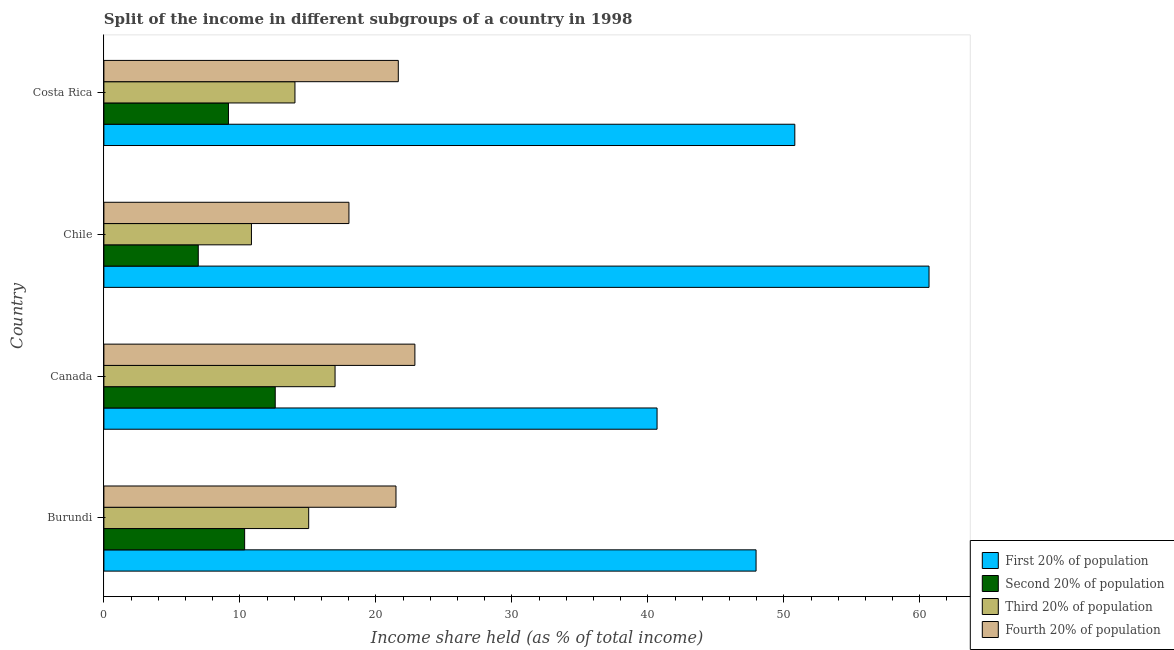How many different coloured bars are there?
Provide a succinct answer. 4. How many groups of bars are there?
Keep it short and to the point. 4. How many bars are there on the 1st tick from the top?
Your answer should be very brief. 4. How many bars are there on the 2nd tick from the bottom?
Offer a terse response. 4. What is the label of the 2nd group of bars from the top?
Give a very brief answer. Chile. What is the share of the income held by second 20% of the population in Chile?
Ensure brevity in your answer.  6.94. Across all countries, what is the maximum share of the income held by first 20% of the population?
Make the answer very short. 60.68. Across all countries, what is the minimum share of the income held by second 20% of the population?
Your answer should be compact. 6.94. What is the total share of the income held by third 20% of the population in the graph?
Give a very brief answer. 56.96. What is the difference between the share of the income held by second 20% of the population in Burundi and that in Canada?
Make the answer very short. -2.25. What is the difference between the share of the income held by third 20% of the population in Canada and the share of the income held by second 20% of the population in Chile?
Keep it short and to the point. 10.06. What is the average share of the income held by first 20% of the population per country?
Your response must be concise. 50.03. What is the difference between the share of the income held by first 20% of the population and share of the income held by third 20% of the population in Canada?
Your answer should be very brief. 23.68. In how many countries, is the share of the income held by second 20% of the population greater than 54 %?
Offer a terse response. 0. What is the ratio of the share of the income held by first 20% of the population in Burundi to that in Canada?
Your answer should be compact. 1.18. Is the share of the income held by first 20% of the population in Canada less than that in Chile?
Ensure brevity in your answer.  Yes. What is the difference between the highest and the second highest share of the income held by first 20% of the population?
Keep it short and to the point. 9.87. What is the difference between the highest and the lowest share of the income held by third 20% of the population?
Provide a succinct answer. 6.15. Is the sum of the share of the income held by first 20% of the population in Chile and Costa Rica greater than the maximum share of the income held by second 20% of the population across all countries?
Provide a short and direct response. Yes. What does the 1st bar from the top in Burundi represents?
Offer a very short reply. Fourth 20% of population. What does the 3rd bar from the bottom in Burundi represents?
Your response must be concise. Third 20% of population. Are all the bars in the graph horizontal?
Make the answer very short. Yes. How many countries are there in the graph?
Give a very brief answer. 4. Does the graph contain any zero values?
Your response must be concise. No. Does the graph contain grids?
Provide a short and direct response. No. Where does the legend appear in the graph?
Give a very brief answer. Bottom right. How many legend labels are there?
Give a very brief answer. 4. What is the title of the graph?
Provide a succinct answer. Split of the income in different subgroups of a country in 1998. What is the label or title of the X-axis?
Make the answer very short. Income share held (as % of total income). What is the label or title of the Y-axis?
Your answer should be very brief. Country. What is the Income share held (as % of total income) of First 20% of population in Burundi?
Give a very brief answer. 47.96. What is the Income share held (as % of total income) of Second 20% of population in Burundi?
Your answer should be very brief. 10.35. What is the Income share held (as % of total income) of Third 20% of population in Burundi?
Provide a succinct answer. 15.06. What is the Income share held (as % of total income) of Fourth 20% of population in Burundi?
Your response must be concise. 21.48. What is the Income share held (as % of total income) in First 20% of population in Canada?
Provide a succinct answer. 40.68. What is the Income share held (as % of total income) of Third 20% of population in Canada?
Ensure brevity in your answer.  17. What is the Income share held (as % of total income) in Fourth 20% of population in Canada?
Make the answer very short. 22.87. What is the Income share held (as % of total income) in First 20% of population in Chile?
Your response must be concise. 60.68. What is the Income share held (as % of total income) in Second 20% of population in Chile?
Offer a very short reply. 6.94. What is the Income share held (as % of total income) in Third 20% of population in Chile?
Provide a succinct answer. 10.85. What is the Income share held (as % of total income) in Fourth 20% of population in Chile?
Ensure brevity in your answer.  18.02. What is the Income share held (as % of total income) of First 20% of population in Costa Rica?
Provide a succinct answer. 50.81. What is the Income share held (as % of total income) of Second 20% of population in Costa Rica?
Make the answer very short. 9.16. What is the Income share held (as % of total income) of Third 20% of population in Costa Rica?
Offer a very short reply. 14.05. What is the Income share held (as % of total income) in Fourth 20% of population in Costa Rica?
Provide a succinct answer. 21.65. Across all countries, what is the maximum Income share held (as % of total income) in First 20% of population?
Offer a very short reply. 60.68. Across all countries, what is the maximum Income share held (as % of total income) in Second 20% of population?
Your answer should be very brief. 12.6. Across all countries, what is the maximum Income share held (as % of total income) of Fourth 20% of population?
Provide a succinct answer. 22.87. Across all countries, what is the minimum Income share held (as % of total income) in First 20% of population?
Make the answer very short. 40.68. Across all countries, what is the minimum Income share held (as % of total income) in Second 20% of population?
Offer a very short reply. 6.94. Across all countries, what is the minimum Income share held (as % of total income) of Third 20% of population?
Give a very brief answer. 10.85. Across all countries, what is the minimum Income share held (as % of total income) of Fourth 20% of population?
Offer a very short reply. 18.02. What is the total Income share held (as % of total income) in First 20% of population in the graph?
Keep it short and to the point. 200.13. What is the total Income share held (as % of total income) in Second 20% of population in the graph?
Provide a short and direct response. 39.05. What is the total Income share held (as % of total income) in Third 20% of population in the graph?
Offer a terse response. 56.96. What is the total Income share held (as % of total income) in Fourth 20% of population in the graph?
Provide a short and direct response. 84.02. What is the difference between the Income share held (as % of total income) in First 20% of population in Burundi and that in Canada?
Offer a terse response. 7.28. What is the difference between the Income share held (as % of total income) of Second 20% of population in Burundi and that in Canada?
Offer a terse response. -2.25. What is the difference between the Income share held (as % of total income) of Third 20% of population in Burundi and that in Canada?
Your answer should be very brief. -1.94. What is the difference between the Income share held (as % of total income) in Fourth 20% of population in Burundi and that in Canada?
Provide a succinct answer. -1.39. What is the difference between the Income share held (as % of total income) in First 20% of population in Burundi and that in Chile?
Offer a very short reply. -12.72. What is the difference between the Income share held (as % of total income) in Second 20% of population in Burundi and that in Chile?
Provide a short and direct response. 3.41. What is the difference between the Income share held (as % of total income) in Third 20% of population in Burundi and that in Chile?
Provide a short and direct response. 4.21. What is the difference between the Income share held (as % of total income) of Fourth 20% of population in Burundi and that in Chile?
Provide a succinct answer. 3.46. What is the difference between the Income share held (as % of total income) in First 20% of population in Burundi and that in Costa Rica?
Provide a succinct answer. -2.85. What is the difference between the Income share held (as % of total income) of Second 20% of population in Burundi and that in Costa Rica?
Provide a short and direct response. 1.19. What is the difference between the Income share held (as % of total income) of Fourth 20% of population in Burundi and that in Costa Rica?
Provide a succinct answer. -0.17. What is the difference between the Income share held (as % of total income) in First 20% of population in Canada and that in Chile?
Provide a short and direct response. -20. What is the difference between the Income share held (as % of total income) in Second 20% of population in Canada and that in Chile?
Ensure brevity in your answer.  5.66. What is the difference between the Income share held (as % of total income) of Third 20% of population in Canada and that in Chile?
Make the answer very short. 6.15. What is the difference between the Income share held (as % of total income) in Fourth 20% of population in Canada and that in Chile?
Ensure brevity in your answer.  4.85. What is the difference between the Income share held (as % of total income) in First 20% of population in Canada and that in Costa Rica?
Offer a very short reply. -10.13. What is the difference between the Income share held (as % of total income) in Second 20% of population in Canada and that in Costa Rica?
Your answer should be compact. 3.44. What is the difference between the Income share held (as % of total income) of Third 20% of population in Canada and that in Costa Rica?
Your answer should be compact. 2.95. What is the difference between the Income share held (as % of total income) of Fourth 20% of population in Canada and that in Costa Rica?
Give a very brief answer. 1.22. What is the difference between the Income share held (as % of total income) of First 20% of population in Chile and that in Costa Rica?
Give a very brief answer. 9.87. What is the difference between the Income share held (as % of total income) of Second 20% of population in Chile and that in Costa Rica?
Provide a short and direct response. -2.22. What is the difference between the Income share held (as % of total income) in Third 20% of population in Chile and that in Costa Rica?
Ensure brevity in your answer.  -3.2. What is the difference between the Income share held (as % of total income) in Fourth 20% of population in Chile and that in Costa Rica?
Offer a very short reply. -3.63. What is the difference between the Income share held (as % of total income) in First 20% of population in Burundi and the Income share held (as % of total income) in Second 20% of population in Canada?
Provide a short and direct response. 35.36. What is the difference between the Income share held (as % of total income) of First 20% of population in Burundi and the Income share held (as % of total income) of Third 20% of population in Canada?
Provide a short and direct response. 30.96. What is the difference between the Income share held (as % of total income) of First 20% of population in Burundi and the Income share held (as % of total income) of Fourth 20% of population in Canada?
Ensure brevity in your answer.  25.09. What is the difference between the Income share held (as % of total income) of Second 20% of population in Burundi and the Income share held (as % of total income) of Third 20% of population in Canada?
Your answer should be compact. -6.65. What is the difference between the Income share held (as % of total income) of Second 20% of population in Burundi and the Income share held (as % of total income) of Fourth 20% of population in Canada?
Provide a short and direct response. -12.52. What is the difference between the Income share held (as % of total income) in Third 20% of population in Burundi and the Income share held (as % of total income) in Fourth 20% of population in Canada?
Make the answer very short. -7.81. What is the difference between the Income share held (as % of total income) of First 20% of population in Burundi and the Income share held (as % of total income) of Second 20% of population in Chile?
Offer a very short reply. 41.02. What is the difference between the Income share held (as % of total income) in First 20% of population in Burundi and the Income share held (as % of total income) in Third 20% of population in Chile?
Your answer should be very brief. 37.11. What is the difference between the Income share held (as % of total income) of First 20% of population in Burundi and the Income share held (as % of total income) of Fourth 20% of population in Chile?
Offer a terse response. 29.94. What is the difference between the Income share held (as % of total income) in Second 20% of population in Burundi and the Income share held (as % of total income) in Fourth 20% of population in Chile?
Your answer should be compact. -7.67. What is the difference between the Income share held (as % of total income) in Third 20% of population in Burundi and the Income share held (as % of total income) in Fourth 20% of population in Chile?
Make the answer very short. -2.96. What is the difference between the Income share held (as % of total income) in First 20% of population in Burundi and the Income share held (as % of total income) in Second 20% of population in Costa Rica?
Ensure brevity in your answer.  38.8. What is the difference between the Income share held (as % of total income) of First 20% of population in Burundi and the Income share held (as % of total income) of Third 20% of population in Costa Rica?
Keep it short and to the point. 33.91. What is the difference between the Income share held (as % of total income) in First 20% of population in Burundi and the Income share held (as % of total income) in Fourth 20% of population in Costa Rica?
Give a very brief answer. 26.31. What is the difference between the Income share held (as % of total income) in Second 20% of population in Burundi and the Income share held (as % of total income) in Third 20% of population in Costa Rica?
Your answer should be very brief. -3.7. What is the difference between the Income share held (as % of total income) in Second 20% of population in Burundi and the Income share held (as % of total income) in Fourth 20% of population in Costa Rica?
Make the answer very short. -11.3. What is the difference between the Income share held (as % of total income) in Third 20% of population in Burundi and the Income share held (as % of total income) in Fourth 20% of population in Costa Rica?
Ensure brevity in your answer.  -6.59. What is the difference between the Income share held (as % of total income) in First 20% of population in Canada and the Income share held (as % of total income) in Second 20% of population in Chile?
Provide a succinct answer. 33.74. What is the difference between the Income share held (as % of total income) in First 20% of population in Canada and the Income share held (as % of total income) in Third 20% of population in Chile?
Offer a terse response. 29.83. What is the difference between the Income share held (as % of total income) of First 20% of population in Canada and the Income share held (as % of total income) of Fourth 20% of population in Chile?
Make the answer very short. 22.66. What is the difference between the Income share held (as % of total income) of Second 20% of population in Canada and the Income share held (as % of total income) of Third 20% of population in Chile?
Ensure brevity in your answer.  1.75. What is the difference between the Income share held (as % of total income) in Second 20% of population in Canada and the Income share held (as % of total income) in Fourth 20% of population in Chile?
Your response must be concise. -5.42. What is the difference between the Income share held (as % of total income) of Third 20% of population in Canada and the Income share held (as % of total income) of Fourth 20% of population in Chile?
Provide a short and direct response. -1.02. What is the difference between the Income share held (as % of total income) of First 20% of population in Canada and the Income share held (as % of total income) of Second 20% of population in Costa Rica?
Your answer should be very brief. 31.52. What is the difference between the Income share held (as % of total income) in First 20% of population in Canada and the Income share held (as % of total income) in Third 20% of population in Costa Rica?
Your answer should be very brief. 26.63. What is the difference between the Income share held (as % of total income) of First 20% of population in Canada and the Income share held (as % of total income) of Fourth 20% of population in Costa Rica?
Give a very brief answer. 19.03. What is the difference between the Income share held (as % of total income) in Second 20% of population in Canada and the Income share held (as % of total income) in Third 20% of population in Costa Rica?
Offer a terse response. -1.45. What is the difference between the Income share held (as % of total income) in Second 20% of population in Canada and the Income share held (as % of total income) in Fourth 20% of population in Costa Rica?
Provide a succinct answer. -9.05. What is the difference between the Income share held (as % of total income) of Third 20% of population in Canada and the Income share held (as % of total income) of Fourth 20% of population in Costa Rica?
Your answer should be very brief. -4.65. What is the difference between the Income share held (as % of total income) of First 20% of population in Chile and the Income share held (as % of total income) of Second 20% of population in Costa Rica?
Provide a short and direct response. 51.52. What is the difference between the Income share held (as % of total income) in First 20% of population in Chile and the Income share held (as % of total income) in Third 20% of population in Costa Rica?
Provide a succinct answer. 46.63. What is the difference between the Income share held (as % of total income) in First 20% of population in Chile and the Income share held (as % of total income) in Fourth 20% of population in Costa Rica?
Your response must be concise. 39.03. What is the difference between the Income share held (as % of total income) in Second 20% of population in Chile and the Income share held (as % of total income) in Third 20% of population in Costa Rica?
Ensure brevity in your answer.  -7.11. What is the difference between the Income share held (as % of total income) in Second 20% of population in Chile and the Income share held (as % of total income) in Fourth 20% of population in Costa Rica?
Your answer should be compact. -14.71. What is the average Income share held (as % of total income) of First 20% of population per country?
Provide a short and direct response. 50.03. What is the average Income share held (as % of total income) of Second 20% of population per country?
Keep it short and to the point. 9.76. What is the average Income share held (as % of total income) in Third 20% of population per country?
Give a very brief answer. 14.24. What is the average Income share held (as % of total income) in Fourth 20% of population per country?
Give a very brief answer. 21. What is the difference between the Income share held (as % of total income) of First 20% of population and Income share held (as % of total income) of Second 20% of population in Burundi?
Keep it short and to the point. 37.61. What is the difference between the Income share held (as % of total income) of First 20% of population and Income share held (as % of total income) of Third 20% of population in Burundi?
Make the answer very short. 32.9. What is the difference between the Income share held (as % of total income) of First 20% of population and Income share held (as % of total income) of Fourth 20% of population in Burundi?
Provide a succinct answer. 26.48. What is the difference between the Income share held (as % of total income) of Second 20% of population and Income share held (as % of total income) of Third 20% of population in Burundi?
Your answer should be very brief. -4.71. What is the difference between the Income share held (as % of total income) of Second 20% of population and Income share held (as % of total income) of Fourth 20% of population in Burundi?
Your response must be concise. -11.13. What is the difference between the Income share held (as % of total income) of Third 20% of population and Income share held (as % of total income) of Fourth 20% of population in Burundi?
Provide a succinct answer. -6.42. What is the difference between the Income share held (as % of total income) of First 20% of population and Income share held (as % of total income) of Second 20% of population in Canada?
Your answer should be very brief. 28.08. What is the difference between the Income share held (as % of total income) of First 20% of population and Income share held (as % of total income) of Third 20% of population in Canada?
Keep it short and to the point. 23.68. What is the difference between the Income share held (as % of total income) of First 20% of population and Income share held (as % of total income) of Fourth 20% of population in Canada?
Make the answer very short. 17.81. What is the difference between the Income share held (as % of total income) in Second 20% of population and Income share held (as % of total income) in Third 20% of population in Canada?
Keep it short and to the point. -4.4. What is the difference between the Income share held (as % of total income) in Second 20% of population and Income share held (as % of total income) in Fourth 20% of population in Canada?
Offer a very short reply. -10.27. What is the difference between the Income share held (as % of total income) of Third 20% of population and Income share held (as % of total income) of Fourth 20% of population in Canada?
Your response must be concise. -5.87. What is the difference between the Income share held (as % of total income) in First 20% of population and Income share held (as % of total income) in Second 20% of population in Chile?
Offer a very short reply. 53.74. What is the difference between the Income share held (as % of total income) in First 20% of population and Income share held (as % of total income) in Third 20% of population in Chile?
Give a very brief answer. 49.83. What is the difference between the Income share held (as % of total income) of First 20% of population and Income share held (as % of total income) of Fourth 20% of population in Chile?
Your answer should be compact. 42.66. What is the difference between the Income share held (as % of total income) in Second 20% of population and Income share held (as % of total income) in Third 20% of population in Chile?
Your answer should be very brief. -3.91. What is the difference between the Income share held (as % of total income) in Second 20% of population and Income share held (as % of total income) in Fourth 20% of population in Chile?
Make the answer very short. -11.08. What is the difference between the Income share held (as % of total income) of Third 20% of population and Income share held (as % of total income) of Fourth 20% of population in Chile?
Your answer should be compact. -7.17. What is the difference between the Income share held (as % of total income) of First 20% of population and Income share held (as % of total income) of Second 20% of population in Costa Rica?
Make the answer very short. 41.65. What is the difference between the Income share held (as % of total income) in First 20% of population and Income share held (as % of total income) in Third 20% of population in Costa Rica?
Make the answer very short. 36.76. What is the difference between the Income share held (as % of total income) of First 20% of population and Income share held (as % of total income) of Fourth 20% of population in Costa Rica?
Your response must be concise. 29.16. What is the difference between the Income share held (as % of total income) in Second 20% of population and Income share held (as % of total income) in Third 20% of population in Costa Rica?
Ensure brevity in your answer.  -4.89. What is the difference between the Income share held (as % of total income) of Second 20% of population and Income share held (as % of total income) of Fourth 20% of population in Costa Rica?
Your answer should be very brief. -12.49. What is the ratio of the Income share held (as % of total income) of First 20% of population in Burundi to that in Canada?
Make the answer very short. 1.18. What is the ratio of the Income share held (as % of total income) of Second 20% of population in Burundi to that in Canada?
Provide a succinct answer. 0.82. What is the ratio of the Income share held (as % of total income) of Third 20% of population in Burundi to that in Canada?
Your answer should be compact. 0.89. What is the ratio of the Income share held (as % of total income) of Fourth 20% of population in Burundi to that in Canada?
Make the answer very short. 0.94. What is the ratio of the Income share held (as % of total income) in First 20% of population in Burundi to that in Chile?
Provide a succinct answer. 0.79. What is the ratio of the Income share held (as % of total income) in Second 20% of population in Burundi to that in Chile?
Your answer should be compact. 1.49. What is the ratio of the Income share held (as % of total income) in Third 20% of population in Burundi to that in Chile?
Provide a succinct answer. 1.39. What is the ratio of the Income share held (as % of total income) in Fourth 20% of population in Burundi to that in Chile?
Ensure brevity in your answer.  1.19. What is the ratio of the Income share held (as % of total income) in First 20% of population in Burundi to that in Costa Rica?
Make the answer very short. 0.94. What is the ratio of the Income share held (as % of total income) of Second 20% of population in Burundi to that in Costa Rica?
Your answer should be compact. 1.13. What is the ratio of the Income share held (as % of total income) of Third 20% of population in Burundi to that in Costa Rica?
Provide a short and direct response. 1.07. What is the ratio of the Income share held (as % of total income) in Fourth 20% of population in Burundi to that in Costa Rica?
Ensure brevity in your answer.  0.99. What is the ratio of the Income share held (as % of total income) in First 20% of population in Canada to that in Chile?
Ensure brevity in your answer.  0.67. What is the ratio of the Income share held (as % of total income) in Second 20% of population in Canada to that in Chile?
Provide a short and direct response. 1.82. What is the ratio of the Income share held (as % of total income) of Third 20% of population in Canada to that in Chile?
Provide a succinct answer. 1.57. What is the ratio of the Income share held (as % of total income) of Fourth 20% of population in Canada to that in Chile?
Keep it short and to the point. 1.27. What is the ratio of the Income share held (as % of total income) in First 20% of population in Canada to that in Costa Rica?
Offer a very short reply. 0.8. What is the ratio of the Income share held (as % of total income) of Second 20% of population in Canada to that in Costa Rica?
Your answer should be compact. 1.38. What is the ratio of the Income share held (as % of total income) of Third 20% of population in Canada to that in Costa Rica?
Your answer should be compact. 1.21. What is the ratio of the Income share held (as % of total income) of Fourth 20% of population in Canada to that in Costa Rica?
Make the answer very short. 1.06. What is the ratio of the Income share held (as % of total income) of First 20% of population in Chile to that in Costa Rica?
Make the answer very short. 1.19. What is the ratio of the Income share held (as % of total income) of Second 20% of population in Chile to that in Costa Rica?
Your answer should be very brief. 0.76. What is the ratio of the Income share held (as % of total income) in Third 20% of population in Chile to that in Costa Rica?
Offer a very short reply. 0.77. What is the ratio of the Income share held (as % of total income) in Fourth 20% of population in Chile to that in Costa Rica?
Your response must be concise. 0.83. What is the difference between the highest and the second highest Income share held (as % of total income) in First 20% of population?
Your answer should be compact. 9.87. What is the difference between the highest and the second highest Income share held (as % of total income) of Second 20% of population?
Your answer should be very brief. 2.25. What is the difference between the highest and the second highest Income share held (as % of total income) in Third 20% of population?
Your answer should be very brief. 1.94. What is the difference between the highest and the second highest Income share held (as % of total income) in Fourth 20% of population?
Offer a very short reply. 1.22. What is the difference between the highest and the lowest Income share held (as % of total income) in First 20% of population?
Ensure brevity in your answer.  20. What is the difference between the highest and the lowest Income share held (as % of total income) of Second 20% of population?
Offer a terse response. 5.66. What is the difference between the highest and the lowest Income share held (as % of total income) of Third 20% of population?
Give a very brief answer. 6.15. What is the difference between the highest and the lowest Income share held (as % of total income) in Fourth 20% of population?
Provide a succinct answer. 4.85. 